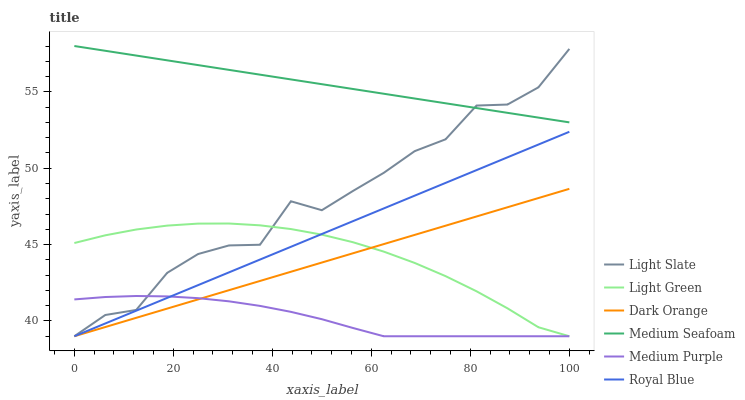Does Medium Purple have the minimum area under the curve?
Answer yes or no. Yes. Does Medium Seafoam have the maximum area under the curve?
Answer yes or no. Yes. Does Light Slate have the minimum area under the curve?
Answer yes or no. No. Does Light Slate have the maximum area under the curve?
Answer yes or no. No. Is Medium Seafoam the smoothest?
Answer yes or no. Yes. Is Light Slate the roughest?
Answer yes or no. Yes. Is Medium Purple the smoothest?
Answer yes or no. No. Is Medium Purple the roughest?
Answer yes or no. No. Does Medium Seafoam have the lowest value?
Answer yes or no. No. Does Medium Seafoam have the highest value?
Answer yes or no. Yes. Does Light Slate have the highest value?
Answer yes or no. No. Is Medium Purple less than Medium Seafoam?
Answer yes or no. Yes. Is Medium Seafoam greater than Dark Orange?
Answer yes or no. Yes. Does Royal Blue intersect Medium Purple?
Answer yes or no. Yes. Is Royal Blue less than Medium Purple?
Answer yes or no. No. Is Royal Blue greater than Medium Purple?
Answer yes or no. No. Does Medium Purple intersect Medium Seafoam?
Answer yes or no. No. 